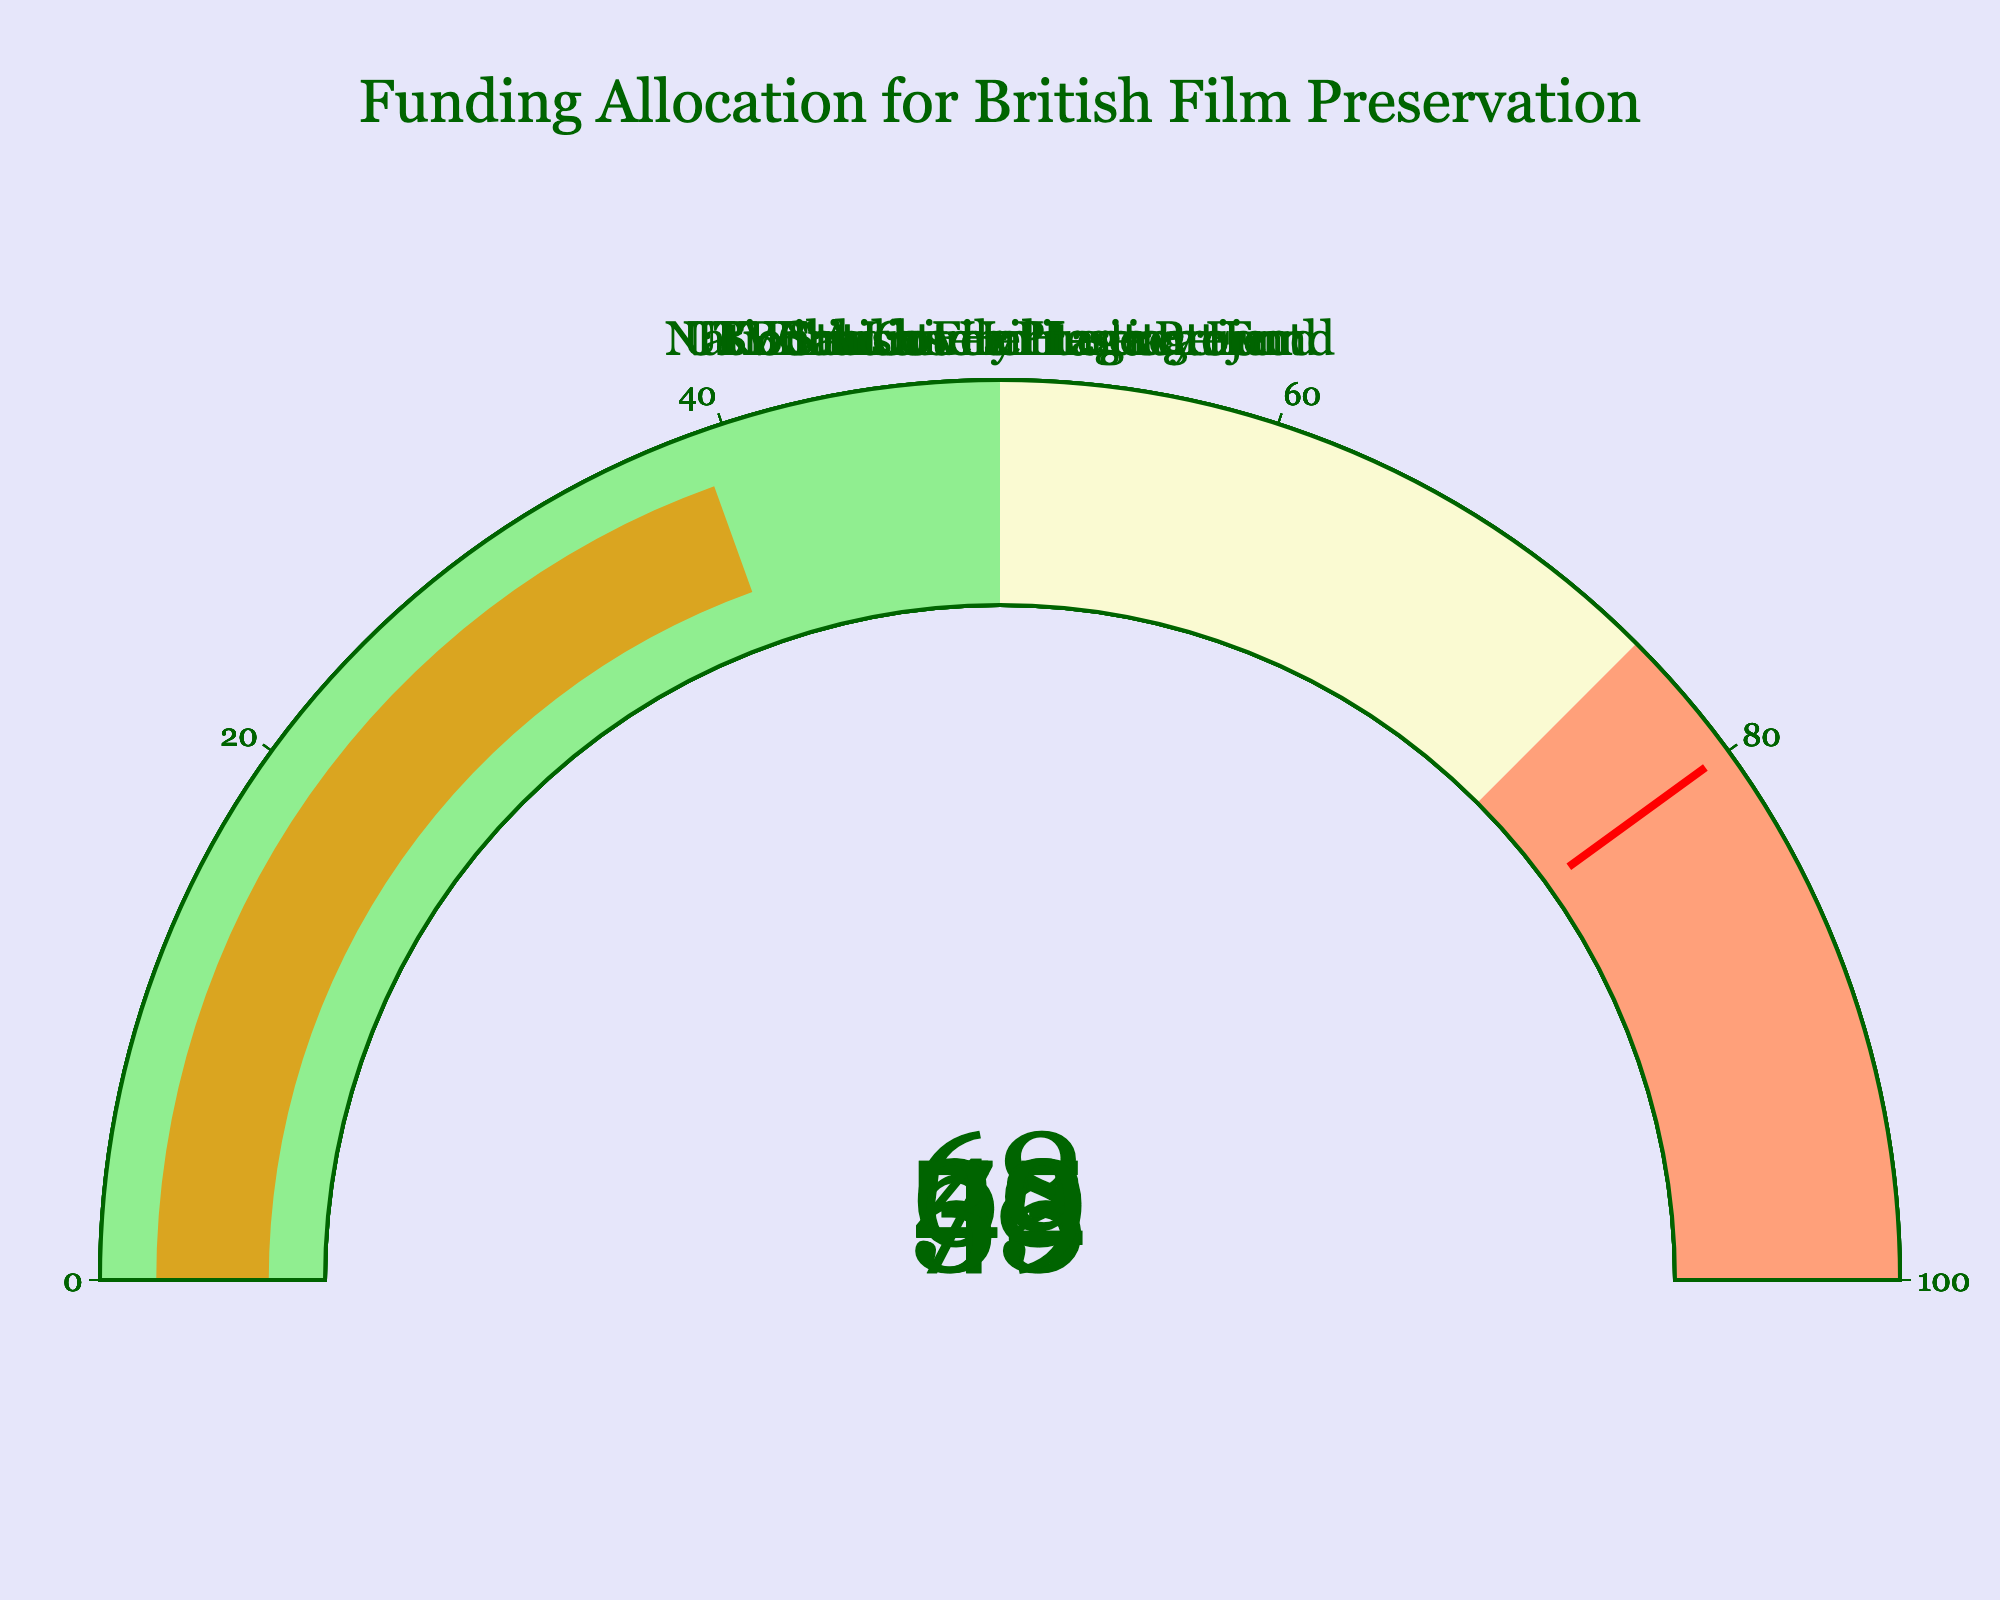What is the highest funding allocation percentage shown on the gauges? The highest funding allocation percentage can be identified by looking at the numbers shown on the gauges and noting the highest value. The British Film Institute has the highest percentage with 78%.
Answer: 78% What are the different colours used on the gauges and what do they represent? The different colours on the gauges represent various ranges of percentages. Light green represents 0-50%, light goldenrod yellow represents 50-75%, and lightsalmon represents 75-100%.
Answer: Light green, light goldenrod yellow, lightsalmon Which organization has the lowest funding allocation percentage? By examining each gauge, the organization with the smallest percentage value is the ITV Studios Heritage Project with 39%.
Answer: ITV Studios Heritage Project What is the exact funding allocation percentage for the BBC Archives Preservation? The gauge for BBC Archives Preservation shows the value at 53%.
Answer: 53% How many organizations have a funding allocation percentage above 50%? To determine this, count the number of organizations with percentages higher than 50%. The British Film Institute, National Lottery Heritage Fund, and BBC Archives Preservation all have percentages above 50%.
Answer: 3 What's the average funding allocation percentage across all the organizations? Sum up all the funding percentages and then divide by the number of organizations: (78 + 62 + 45 + 53 + 39) / 5 = 277 / 5 = 55.4
Answer: 55.4 Does the UK Film Council Legacy Fund receive more funding than the ITV Studios Heritage Project? Compare the percentages of the UK Film Council Legacy Fund (45%) to the ITV Studios Heritage Project (39%). The UK Film Council Legacy Fund has a higher percentage.
Answer: Yes What is the combined percentage allocation for the National Lottery Heritage Fund and BBC Archives Preservation? Add the percentage values for the National Lottery Heritage Fund (62%) and BBC Archives Preservation (53%): 62 + 53 = 115
Answer: 115 Which funding allocation percentage is closest to the threshold value of 80%? The threshold value highlighted by the red line is 80%. The British Film Institute with 78% is the closest to this value.
Answer: British Film Institute 